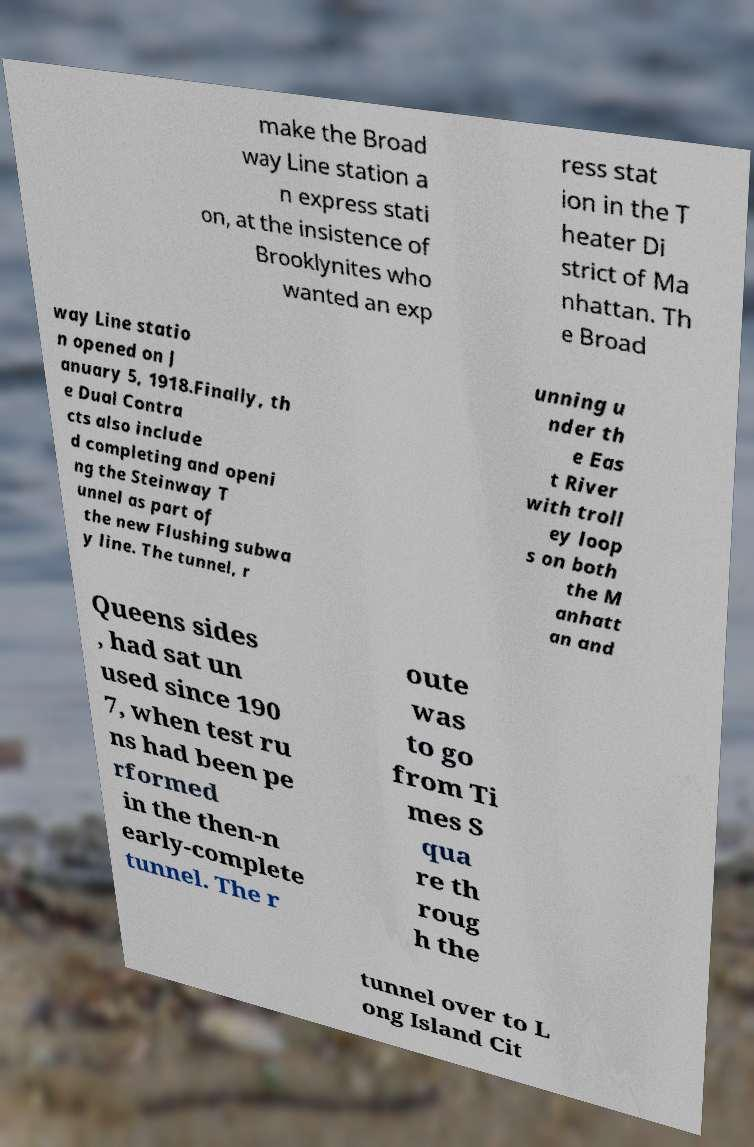Could you assist in decoding the text presented in this image and type it out clearly? make the Broad way Line station a n express stati on, at the insistence of Brooklynites who wanted an exp ress stat ion in the T heater Di strict of Ma nhattan. Th e Broad way Line statio n opened on J anuary 5, 1918.Finally, th e Dual Contra cts also include d completing and openi ng the Steinway T unnel as part of the new Flushing subwa y line. The tunnel, r unning u nder th e Eas t River with troll ey loop s on both the M anhatt an and Queens sides , had sat un used since 190 7, when test ru ns had been pe rformed in the then-n early-complete tunnel. The r oute was to go from Ti mes S qua re th roug h the tunnel over to L ong Island Cit 